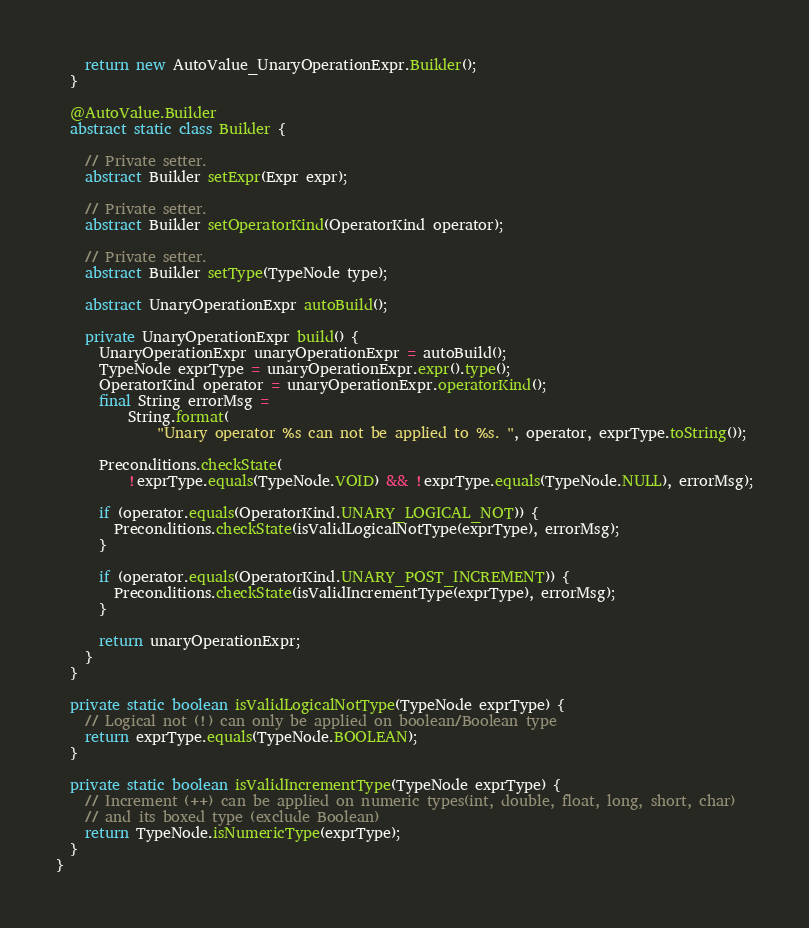<code> <loc_0><loc_0><loc_500><loc_500><_Java_>    return new AutoValue_UnaryOperationExpr.Builder();
  }

  @AutoValue.Builder
  abstract static class Builder {

    // Private setter.
    abstract Builder setExpr(Expr expr);

    // Private setter.
    abstract Builder setOperatorKind(OperatorKind operator);

    // Private setter.
    abstract Builder setType(TypeNode type);

    abstract UnaryOperationExpr autoBuild();

    private UnaryOperationExpr build() {
      UnaryOperationExpr unaryOperationExpr = autoBuild();
      TypeNode exprType = unaryOperationExpr.expr().type();
      OperatorKind operator = unaryOperationExpr.operatorKind();
      final String errorMsg =
          String.format(
              "Unary operator %s can not be applied to %s. ", operator, exprType.toString());

      Preconditions.checkState(
          !exprType.equals(TypeNode.VOID) && !exprType.equals(TypeNode.NULL), errorMsg);

      if (operator.equals(OperatorKind.UNARY_LOGICAL_NOT)) {
        Preconditions.checkState(isValidLogicalNotType(exprType), errorMsg);
      }

      if (operator.equals(OperatorKind.UNARY_POST_INCREMENT)) {
        Preconditions.checkState(isValidIncrementType(exprType), errorMsg);
      }

      return unaryOperationExpr;
    }
  }

  private static boolean isValidLogicalNotType(TypeNode exprType) {
    // Logical not (!) can only be applied on boolean/Boolean type
    return exprType.equals(TypeNode.BOOLEAN);
  }

  private static boolean isValidIncrementType(TypeNode exprType) {
    // Increment (++) can be applied on numeric types(int, double, float, long, short, char)
    // and its boxed type (exclude Boolean)
    return TypeNode.isNumericType(exprType);
  }
}
</code> 